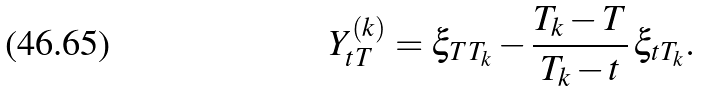Convert formula to latex. <formula><loc_0><loc_0><loc_500><loc_500>Y ^ { ( k ) } _ { t T } = \xi _ { T T _ { k } } - \frac { T _ { k } - T } { T _ { k } - t } \, \xi _ { t T _ { k } } .</formula> 